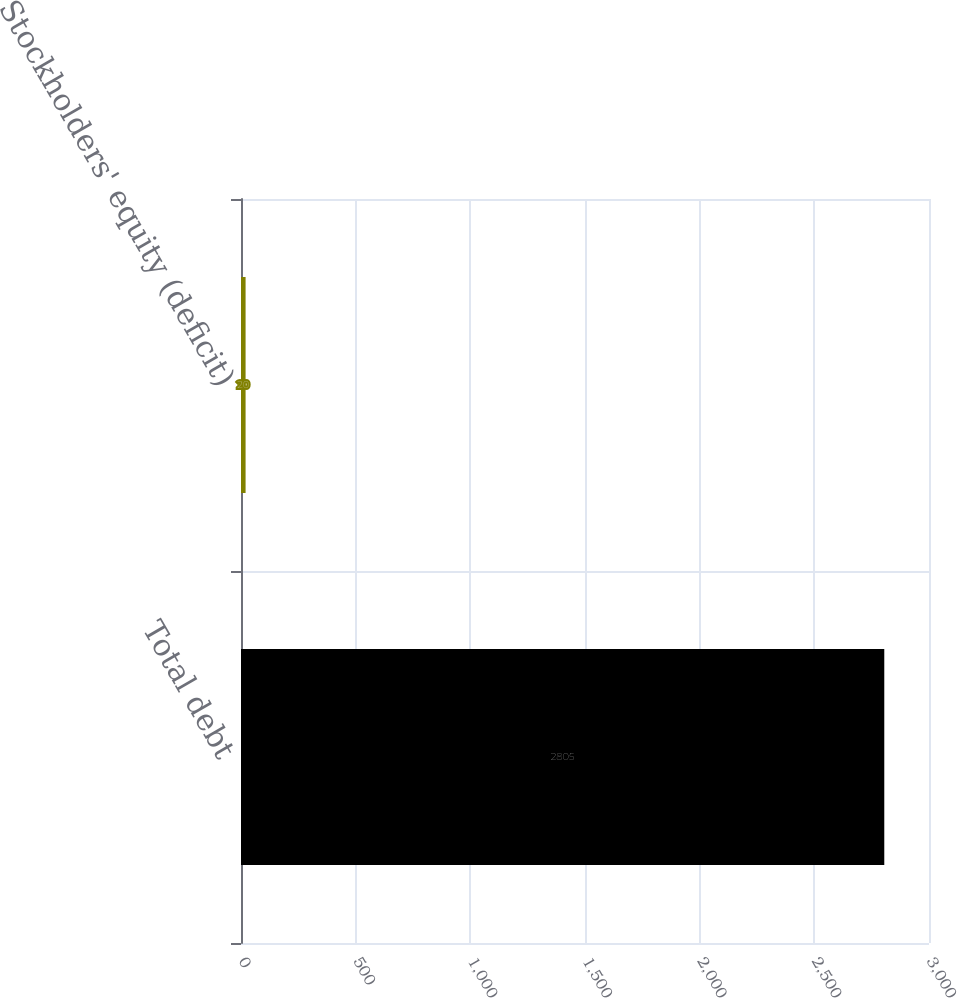Convert chart. <chart><loc_0><loc_0><loc_500><loc_500><bar_chart><fcel>Total debt<fcel>Stockholders' equity (deficit)<nl><fcel>2805<fcel>20<nl></chart> 